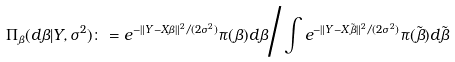Convert formula to latex. <formula><loc_0><loc_0><loc_500><loc_500>\Pi _ { \beta } ( d \beta | Y , \sigma ^ { 2 } ) \colon = e ^ { - \| Y - X \beta \| ^ { 2 } / ( 2 \sigma ^ { 2 } ) } \pi ( \beta ) d \beta \Big { / } \int e ^ { - \| Y - X \tilde { \beta } \| ^ { 2 } / ( 2 \sigma ^ { 2 } ) } \pi ( \tilde { \beta } ) d \tilde { \beta }</formula> 